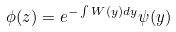Convert formula to latex. <formula><loc_0><loc_0><loc_500><loc_500>\phi ( z ) = e ^ { - \int W ( y ) d y } \psi ( y )</formula> 